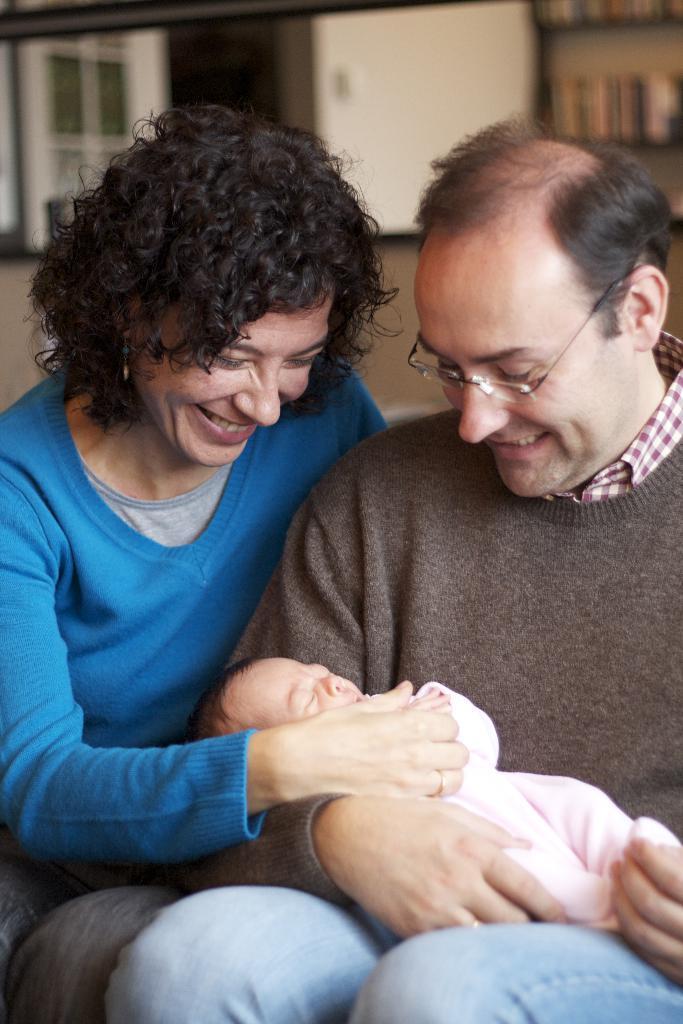Can you describe this image briefly? In this picture we can see a woman and a man, he is holding a baby and he wore spectacles, and also we can see they both are smiling. 